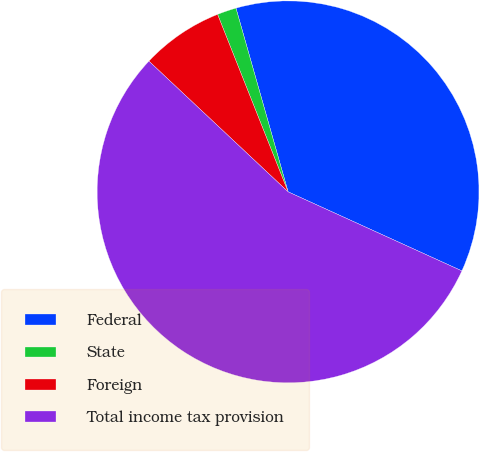<chart> <loc_0><loc_0><loc_500><loc_500><pie_chart><fcel>Federal<fcel>State<fcel>Foreign<fcel>Total income tax provision<nl><fcel>36.2%<fcel>1.62%<fcel>6.98%<fcel>55.21%<nl></chart> 